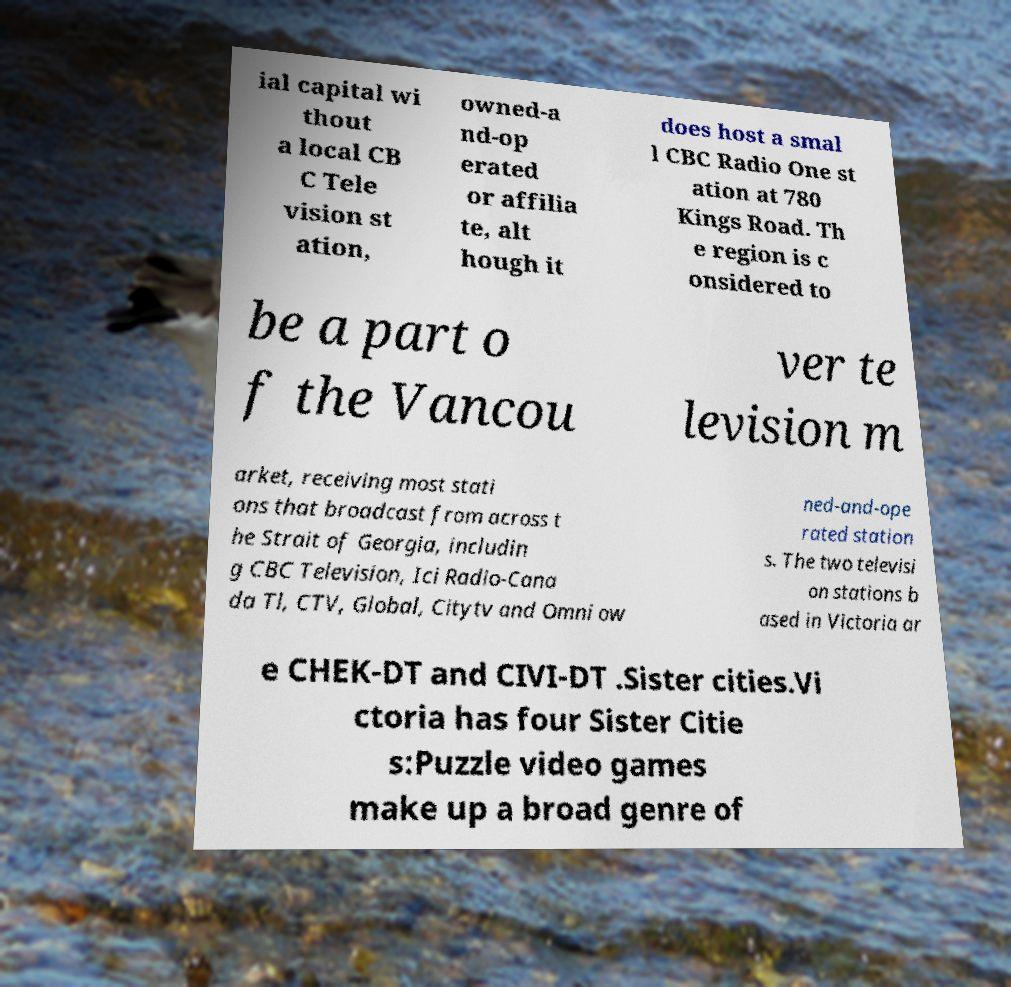Could you assist in decoding the text presented in this image and type it out clearly? ial capital wi thout a local CB C Tele vision st ation, owned-a nd-op erated or affilia te, alt hough it does host a smal l CBC Radio One st ation at 780 Kings Road. Th e region is c onsidered to be a part o f the Vancou ver te levision m arket, receiving most stati ons that broadcast from across t he Strait of Georgia, includin g CBC Television, Ici Radio-Cana da Tl, CTV, Global, Citytv and Omni ow ned-and-ope rated station s. The two televisi on stations b ased in Victoria ar e CHEK-DT and CIVI-DT .Sister cities.Vi ctoria has four Sister Citie s:Puzzle video games make up a broad genre of 